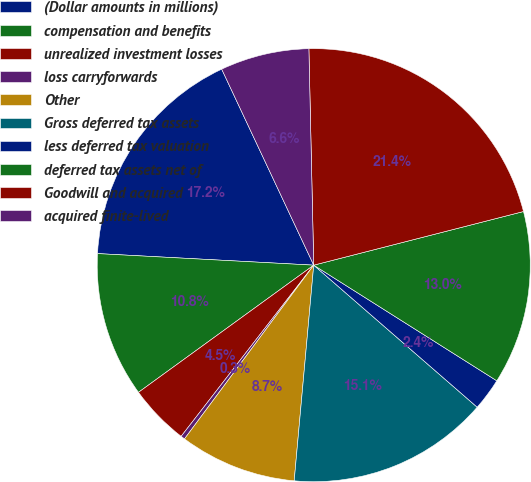<chart> <loc_0><loc_0><loc_500><loc_500><pie_chart><fcel>(Dollar amounts in millions)<fcel>compensation and benefits<fcel>unrealized investment losses<fcel>loss carryforwards<fcel>Other<fcel>Gross deferred tax assets<fcel>less deferred tax valuation<fcel>deferred tax assets net of<fcel>Goodwill and acquired<fcel>acquired finite-lived<nl><fcel>17.16%<fcel>10.84%<fcel>4.52%<fcel>0.31%<fcel>8.74%<fcel>15.05%<fcel>2.42%<fcel>12.95%<fcel>21.37%<fcel>6.63%<nl></chart> 